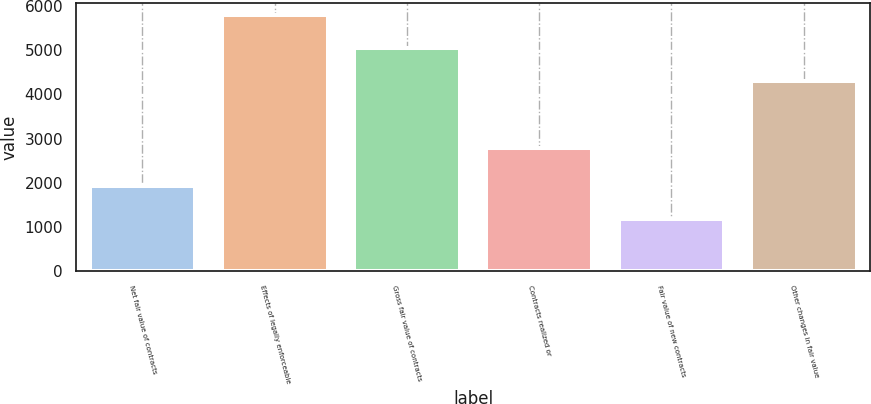Convert chart. <chart><loc_0><loc_0><loc_500><loc_500><bar_chart><fcel>Net fair value of contracts<fcel>Effects of legally enforceable<fcel>Gross fair value of contracts<fcel>Contracts realized or<fcel>Fair value of new contracts<fcel>Other changes in fair value<nl><fcel>1929.5<fcel>5787<fcel>5039.5<fcel>2797<fcel>1182<fcel>4292<nl></chart> 